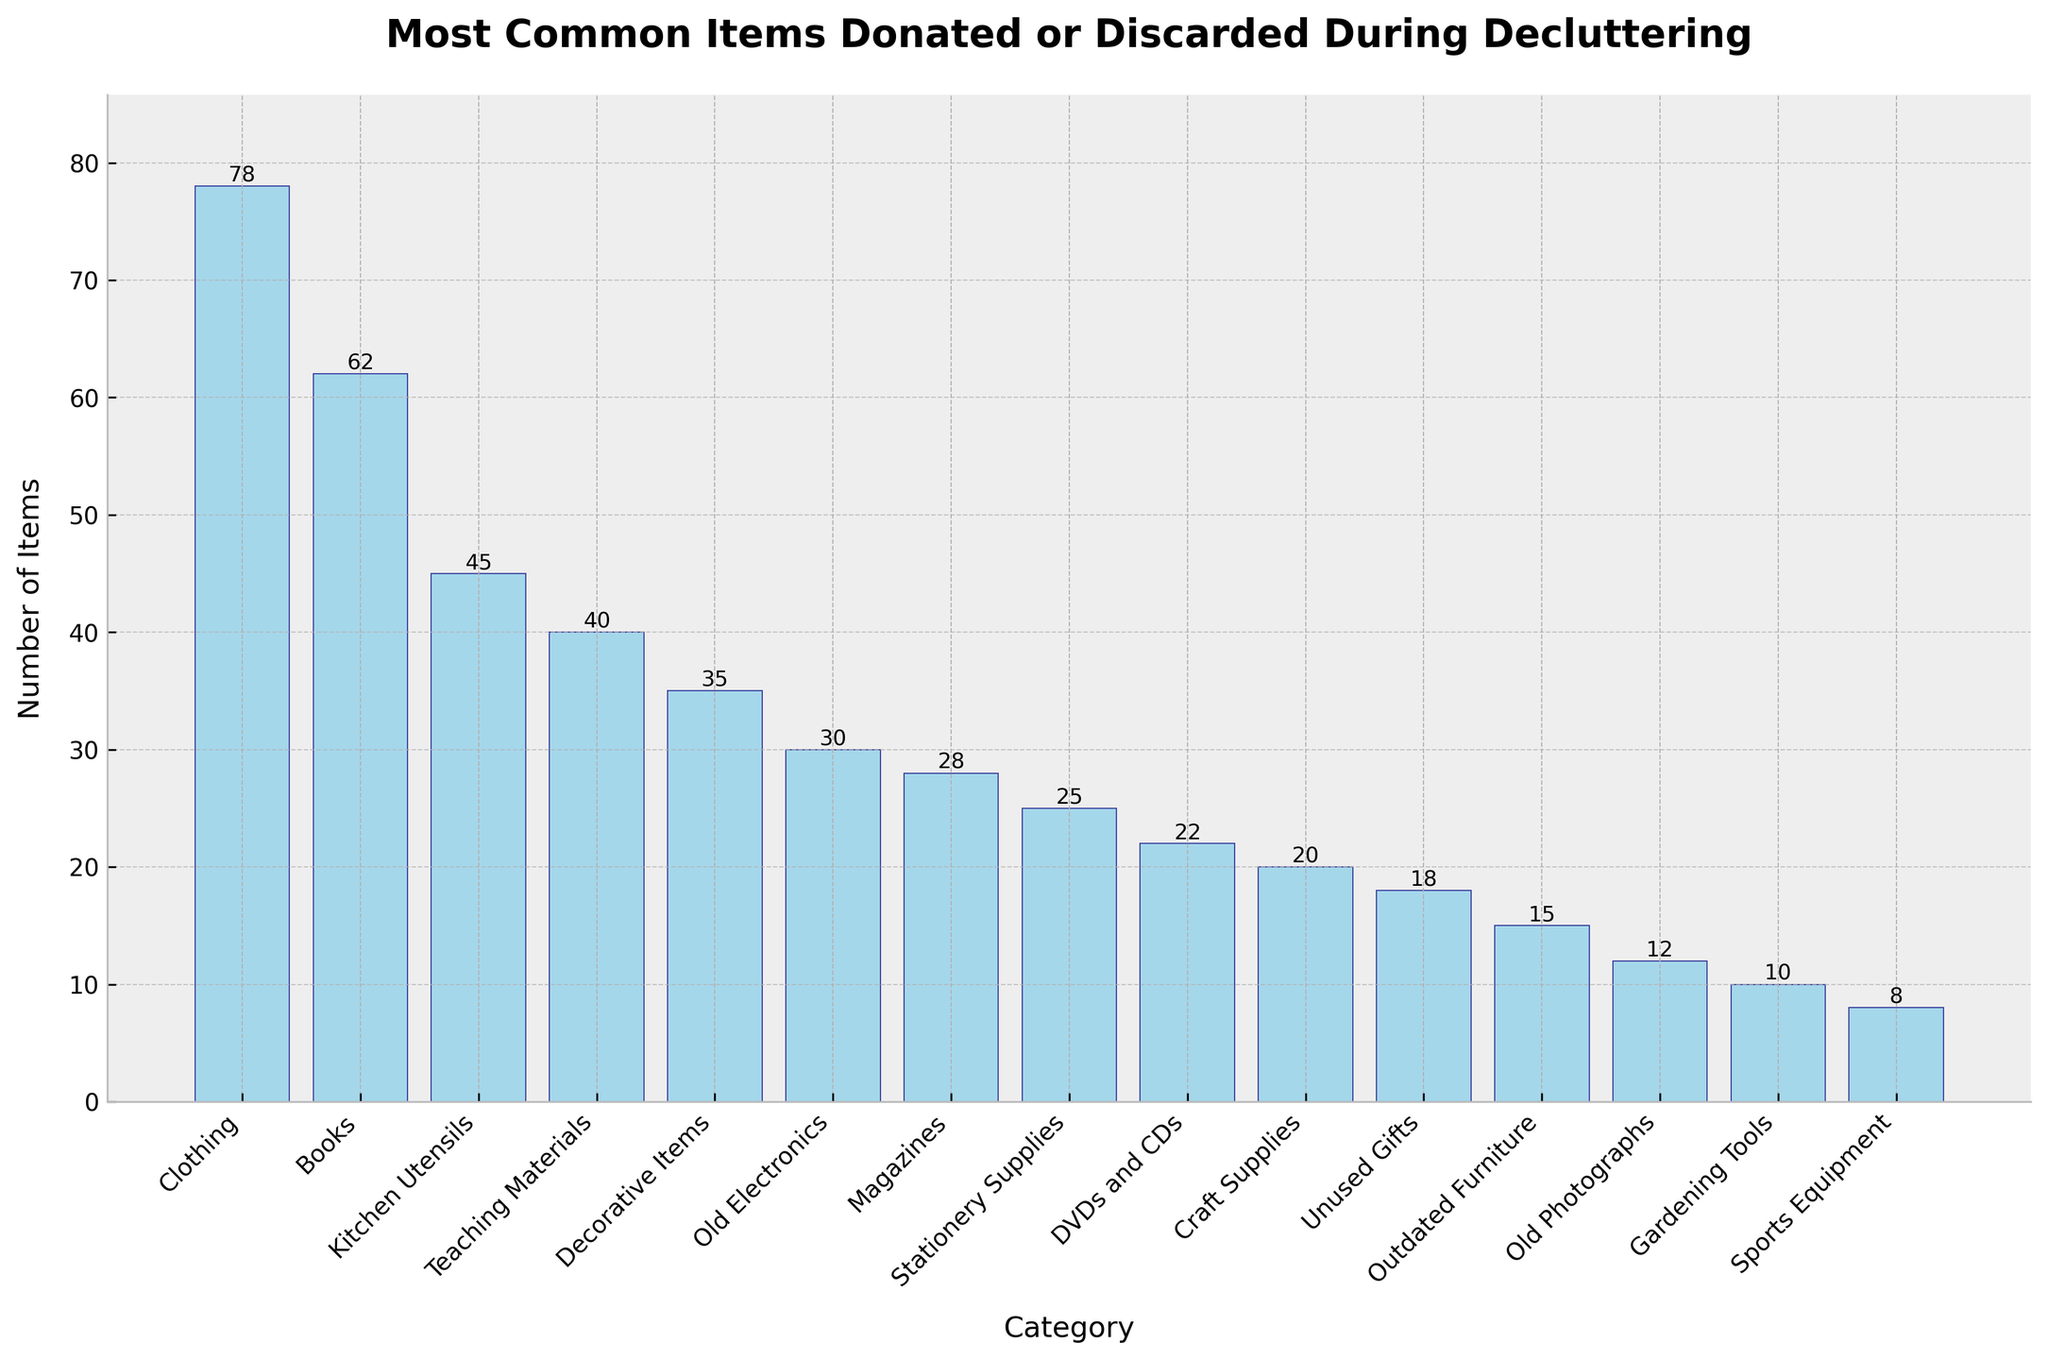Which category has the highest number of items donated or discarded? The category with the highest bar represents the largest number of items. By looking at the heights of the bars, we can see that the "Clothing" category has the highest number.
Answer: Clothing Which category has the second-highest number of items donated or discarded? The second-highest bar corresponds to the second-largest number of items. After "Clothing", the "Books" category has the second-highest bar.
Answer: Books What is the total number of items for the categories "Old Electronics" and "Sports Equipment"? Sum the values for the "Old Electronics" (30 items) and "Sports Equipment" (8 items) categories. 30 + 8 = 38.
Answer: 38 How many more items are there in the "Clothing" category compared to the "Unused Gifts" category? Subtract the number of items in "Unused Gifts" (18 items) from the number of items in "Clothing" (78 items). 78 - 18 = 60.
Answer: 60 What is the average number of items across all categories? Sum all the items from each category (78+62+45+40+35+30+28+25+22+20+18+15+12+10+8 = 448) and divide by the number of categories (15). 448 / 15 ≈ 29.87.
Answer: 29.87 Which category has the least number of items donated or discarded? The shortest bar in the figure indicates the category with the fewest items. The "Sports Equipment" category has the shortest bar with 8 items.
Answer: Sports Equipment Are there more items in the "Books" category or the combined total of "DVDs and CDs" and "Craft Supplies"? First, add the items from "DVDs and CDs" (22) and "Craft Supplies" (20), which equals 42. Then compare it with the number of items in "Books" (62). Since 62 is larger than 42, "Books" has more items.
Answer: Books What is the difference between the highest and the lowest number of items donated or discarded? Subtract the number of items in the "Sports Equipment" category (8) from the number in the "Clothing" category (78). 78 - 8 = 70.
Answer: 70 